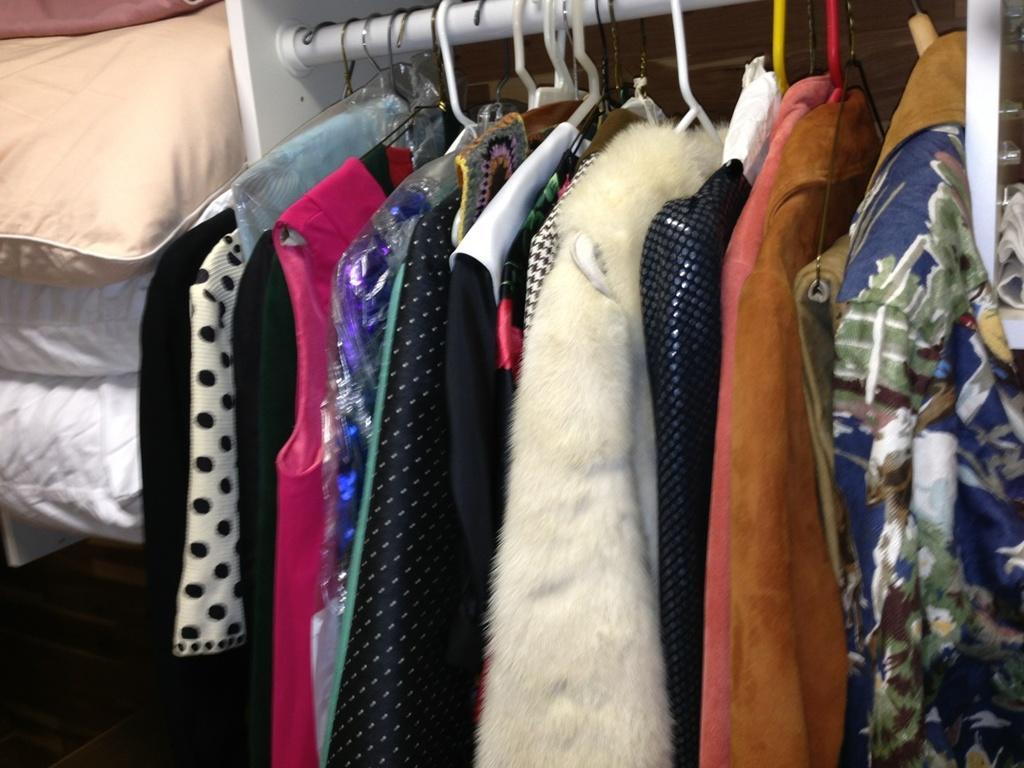How would you summarize this image in a sentence or two? In this image we can see different types of clothes hanged to a rod with the help of hangers and quilts beside them. 